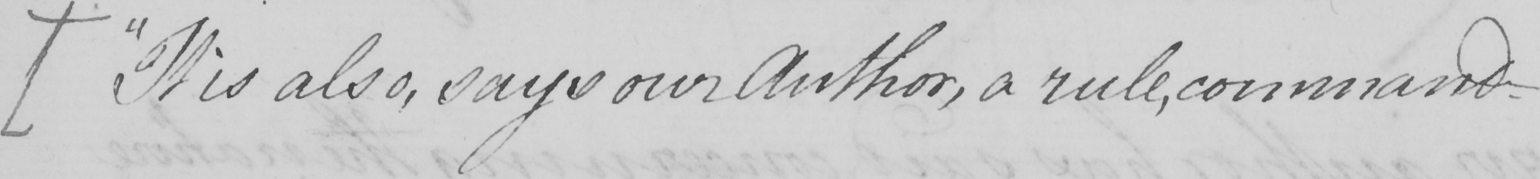What text is written in this handwritten line? ["It is also, says our Author, a rule, command- 